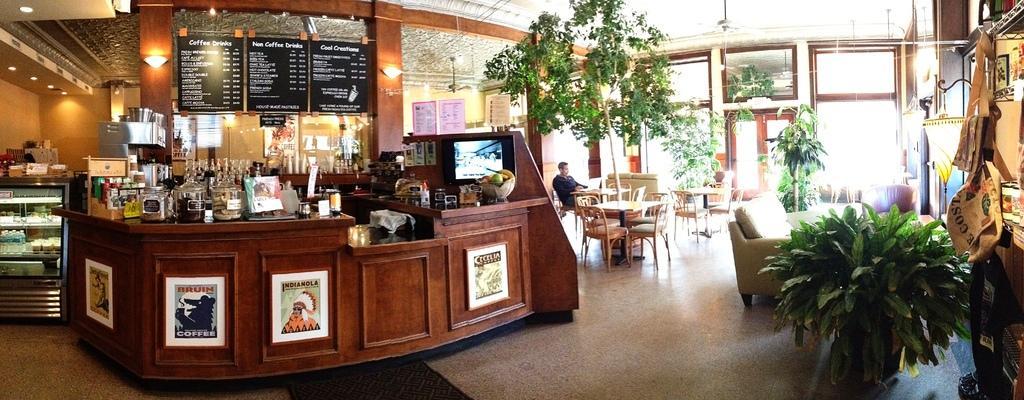Can you describe this image briefly? In this image we can see the tables, chairs, house plants, tree, and there is also a person sitting on the chair which is on the floor. There is also a black color mat. We can see the frames with text and also images. Image also consists of a television, fruits, alcohol bottles, glass jars and some other objects on the wooden counter. We can also see the black color boards with menu. On the left there is a glass shelf with food items and also water bottles. We can also see the plain wall fans, lights and also the ceiling. We can also see the door and also windows. On the right there are some bags. 